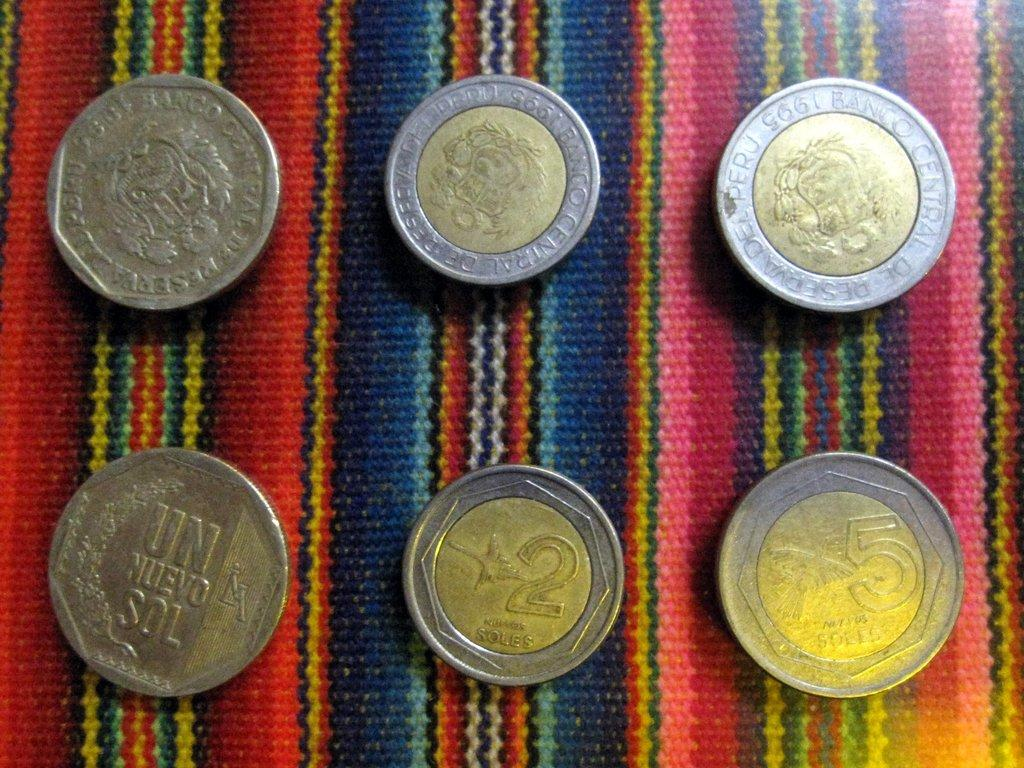Provide a one-sentence caption for the provided image. several coins of silver and bronze on a table including a 2 Soles. 